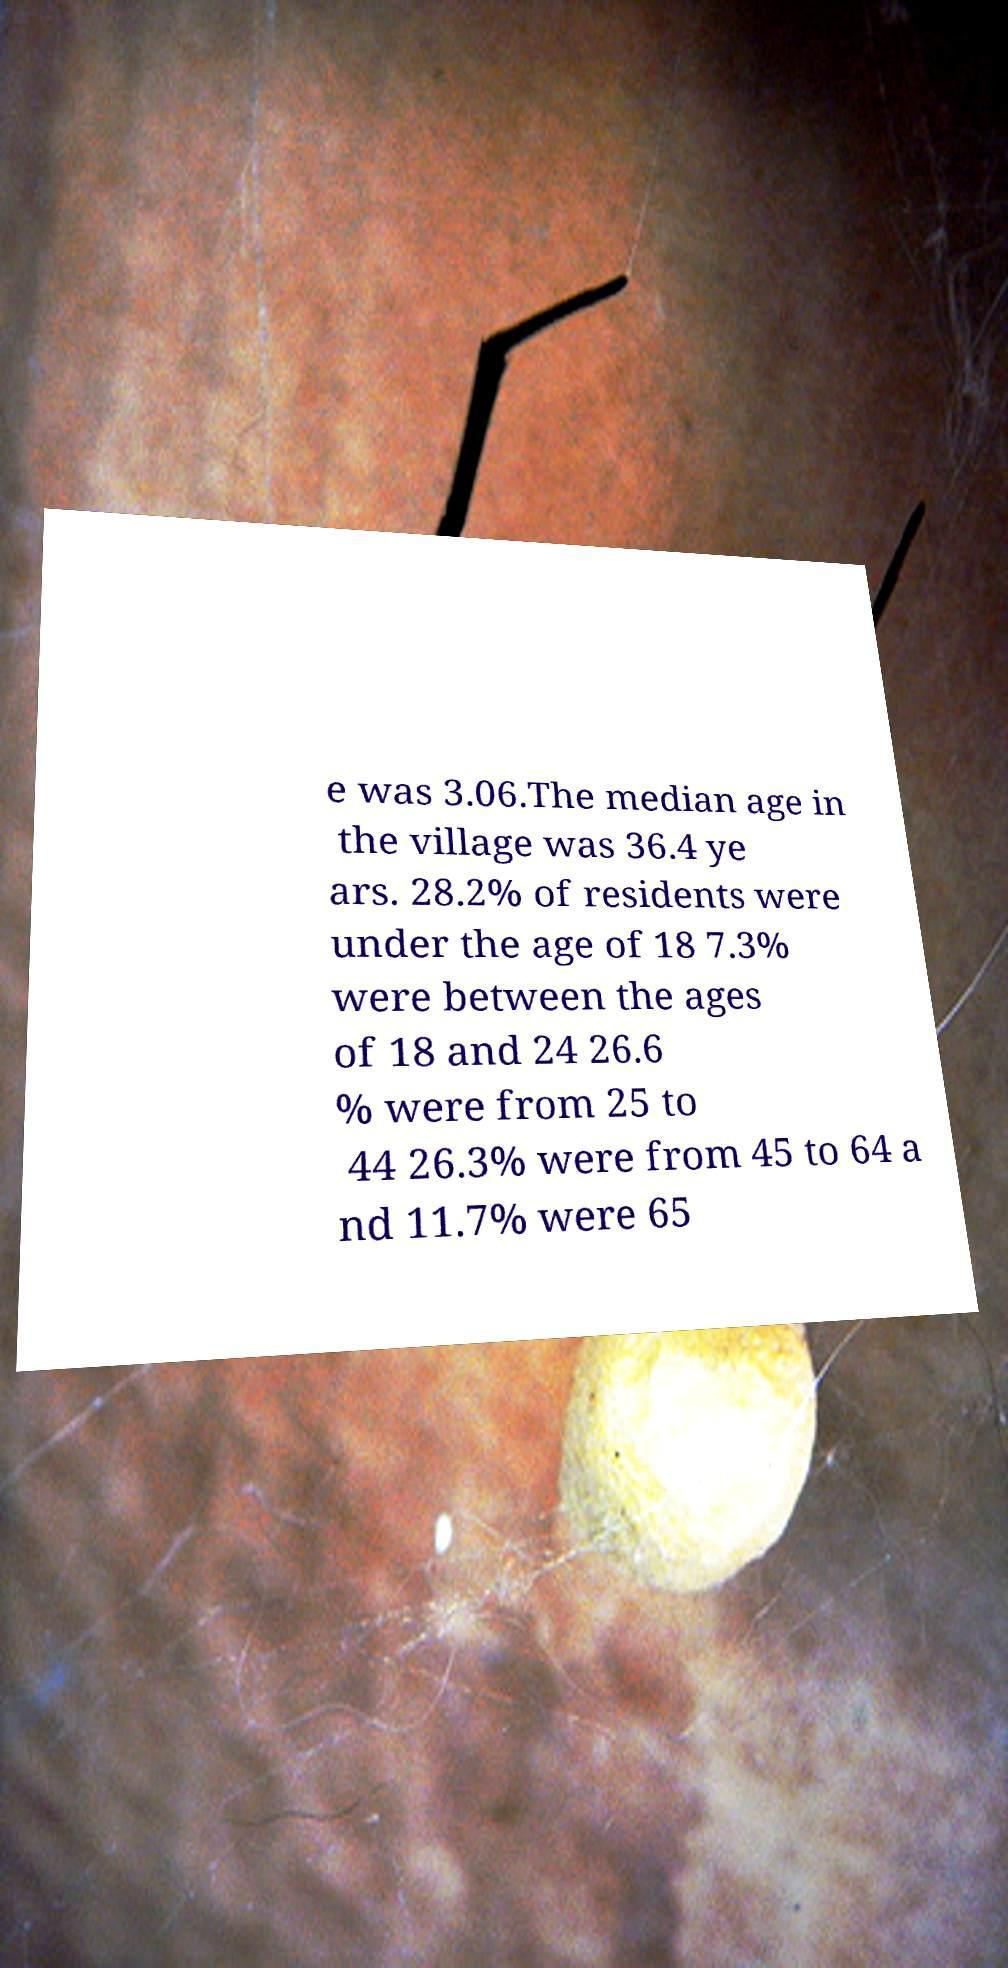Could you assist in decoding the text presented in this image and type it out clearly? e was 3.06.The median age in the village was 36.4 ye ars. 28.2% of residents were under the age of 18 7.3% were between the ages of 18 and 24 26.6 % were from 25 to 44 26.3% were from 45 to 64 a nd 11.7% were 65 